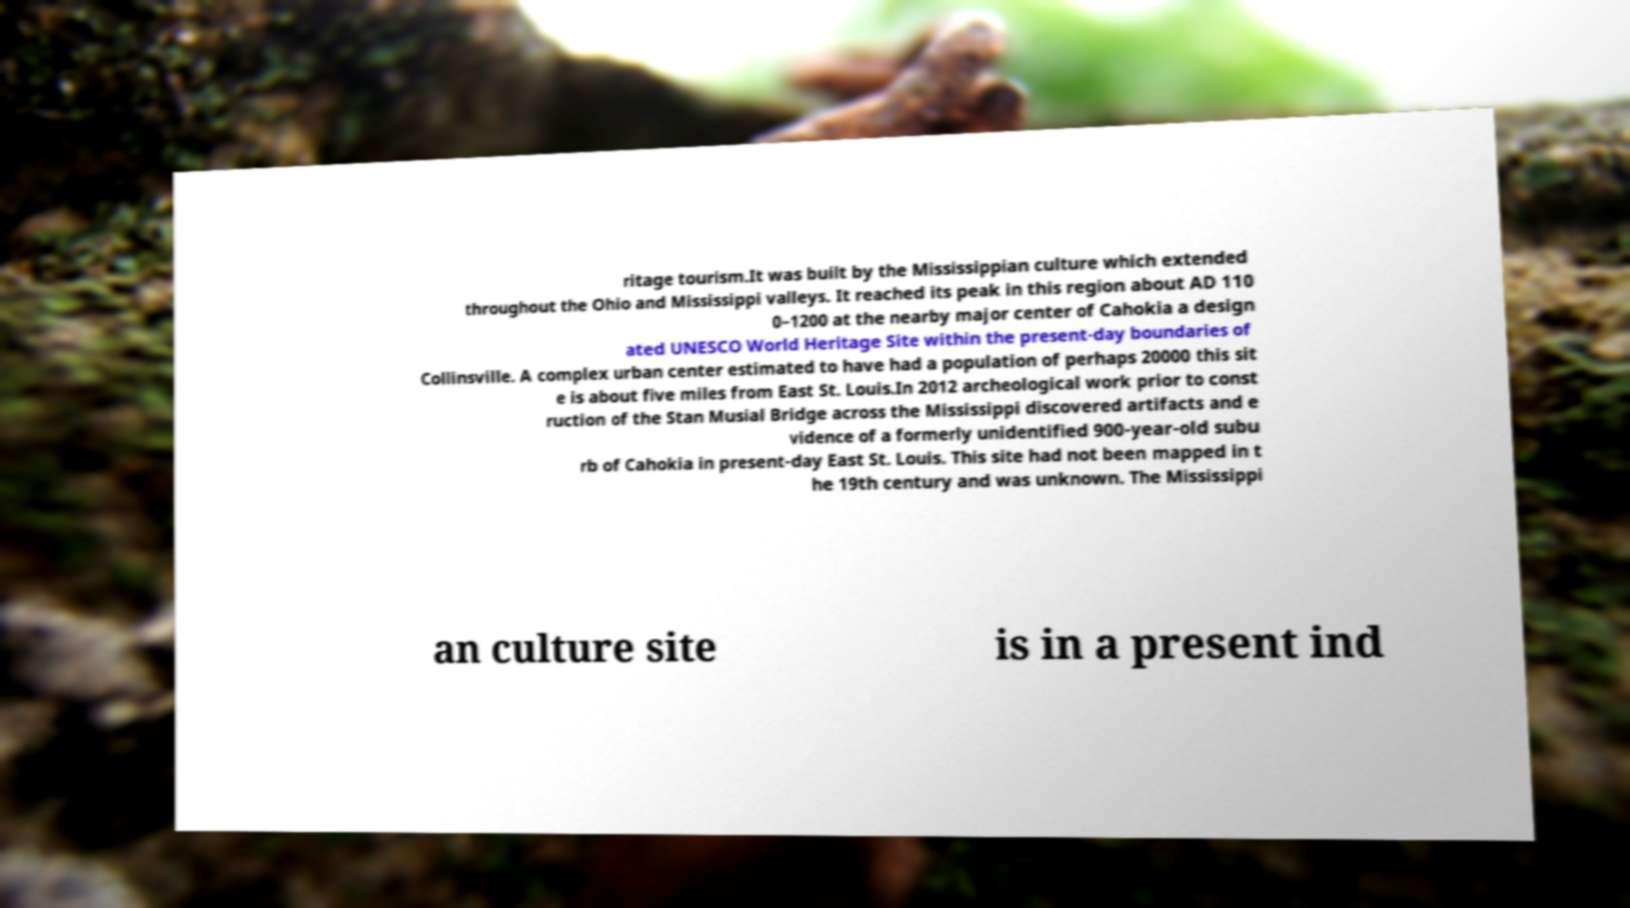For documentation purposes, I need the text within this image transcribed. Could you provide that? ritage tourism.It was built by the Mississippian culture which extended throughout the Ohio and Mississippi valleys. It reached its peak in this region about AD 110 0–1200 at the nearby major center of Cahokia a design ated UNESCO World Heritage Site within the present-day boundaries of Collinsville. A complex urban center estimated to have had a population of perhaps 20000 this sit e is about five miles from East St. Louis.In 2012 archeological work prior to const ruction of the Stan Musial Bridge across the Mississippi discovered artifacts and e vidence of a formerly unidentified 900-year-old subu rb of Cahokia in present-day East St. Louis. This site had not been mapped in t he 19th century and was unknown. The Mississippi an culture site is in a present ind 